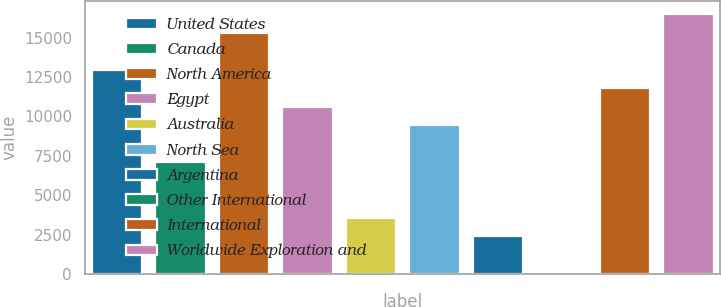<chart> <loc_0><loc_0><loc_500><loc_500><bar_chart><fcel>United States<fcel>Canada<fcel>North America<fcel>Egypt<fcel>Australia<fcel>North Sea<fcel>Argentina<fcel>Other International<fcel>International<fcel>Worldwide Exploration and<nl><fcel>12966.2<fcel>7100.2<fcel>15312.6<fcel>10619.8<fcel>3580.6<fcel>9446.6<fcel>2407.4<fcel>61<fcel>11793<fcel>16485.8<nl></chart> 